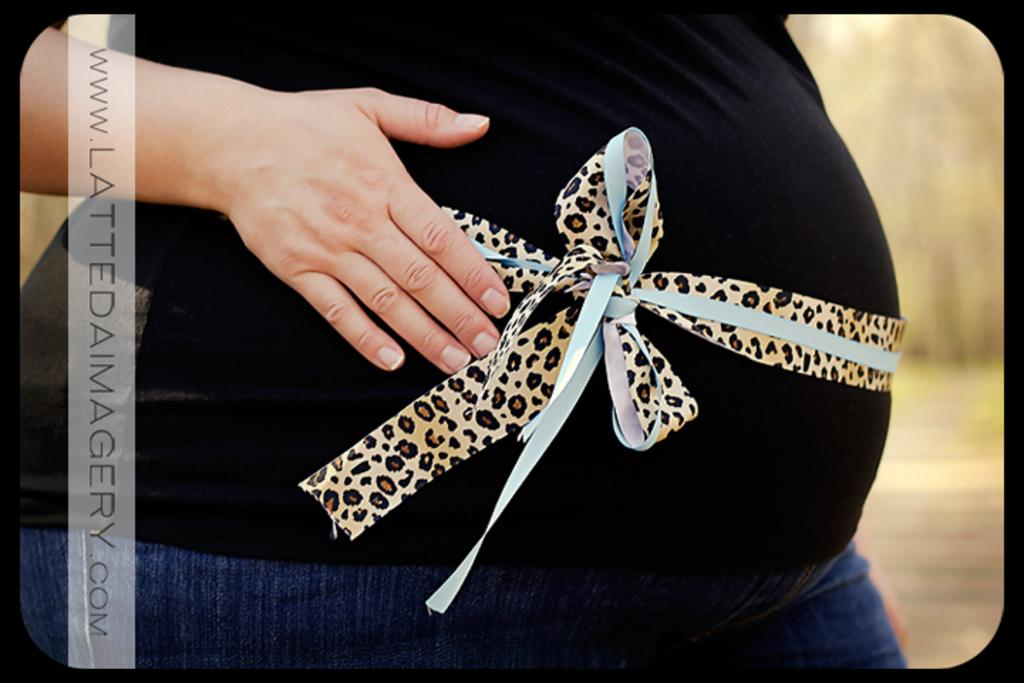Who or what is the main subject in the image? There is a person in the image. What is the person wearing? The person is wearing a black and blue color dress. Are there any accessories or additional features on the person? Yes, there is a ribbon tied to the person's stomach. What type of glass is the person holding in the image? There is no glass present in the image; the person is not holding anything. 